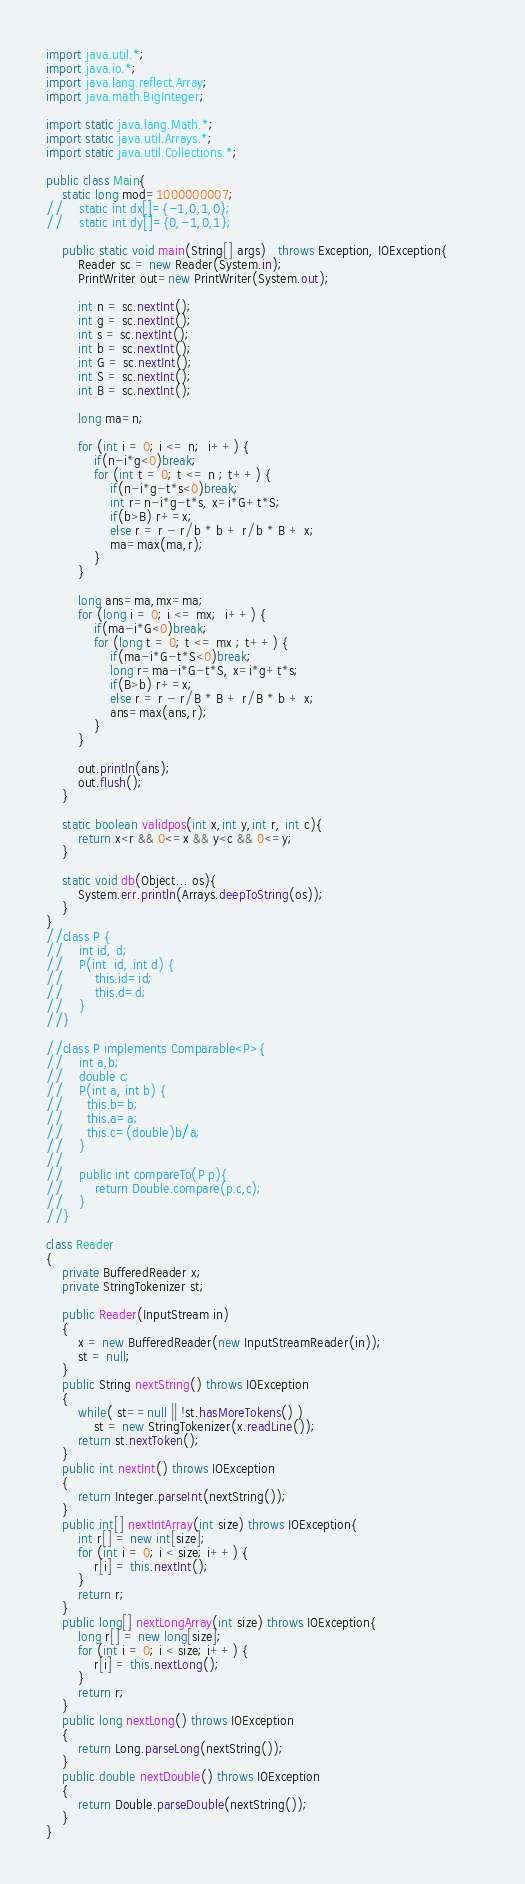Convert code to text. <code><loc_0><loc_0><loc_500><loc_500><_Java_>import java.util.*;
import java.io.*;
import java.lang.reflect.Array;
import java.math.BigInteger;

import static java.lang.Math.*;
import static java.util.Arrays.*;
import static java.util.Collections.*;
 
public class Main{
    static long mod=1000000007;
//    static int dx[]={-1,0,1,0};
//    static int dy[]={0,-1,0,1};

    public static void main(String[] args)   throws Exception, IOException{        
        Reader sc = new Reader(System.in);
        PrintWriter out=new PrintWriter(System.out);

        int n = sc.nextInt();
        int g = sc.nextInt();
        int s = sc.nextInt();
        int b = sc.nextInt();
        int G = sc.nextInt();
        int S = sc.nextInt();
        int B = sc.nextInt();

        long ma=n;
        
        for (int i = 0; i <= n;  i++) {
        	if(n-i*g<0)break;
			for (int t = 0; t <= n ; t++) {
	        	if(n-i*g-t*s<0)break;
				int r=n-i*g-t*s, x=i*G+t*S;
				if(b>B) r+=x;
				else r = r - r/b * b + r/b * B + x;
				ma=max(ma,r);
			}
		}
        
        long ans=ma,mx=ma;
        for (long i = 0; i <= mx;  i++) {
        	if(ma-i*G<0)break;
			for (long t = 0; t <= mx ; t++) {
	        	if(ma-i*G-t*S<0)break;
				long r=ma-i*G-t*S, x=i*g+t*s;
				if(B>b) r+=x;
				else r = r - r/B * B + r/B * b + x;
				ans=max(ans,r);
			}
		}

        out.println(ans);
        out.flush();
    }

    static boolean validpos(int x,int y,int r, int c){
        return x<r && 0<=x && y<c && 0<=y;
    }

    static void db(Object... os){
        System.err.println(Arrays.deepToString(os));
    }
}
//class P {
//    int id, d;
//    P(int  id, int d) {
//        this.id=id;
//        this.d=d;
//    }
//}

//class P implements Comparable<P>{
//    int a,b;
//    double c;
//    P(int a, int b) {
//    	this.b=b;
//    	this.a=a;
//    	this.c=(double)b/a;
//    }
//
//    public int compareTo(P p){
//        return Double.compare(p.c,c);
//    }
//}

class Reader
{ 
    private BufferedReader x;
    private StringTokenizer st;
    
    public Reader(InputStream in)
    {
        x = new BufferedReader(new InputStreamReader(in));
        st = null;
    }
    public String nextString() throws IOException
    {
        while( st==null || !st.hasMoreTokens() )
            st = new StringTokenizer(x.readLine());
        return st.nextToken();
    }
    public int nextInt() throws IOException
    {
        return Integer.parseInt(nextString());
    }
    public int[] nextIntArray(int size) throws IOException{
        int r[] = new int[size];
        for (int i = 0; i < size; i++) {
            r[i] = this.nextInt(); 
        }
        return r;
    }
    public long[] nextLongArray(int size) throws IOException{
        long r[] = new long[size];
        for (int i = 0; i < size; i++) {
            r[i] = this.nextLong(); 
        }
        return r;
    }
    public long nextLong() throws IOException
    {
        return Long.parseLong(nextString());
    }
    public double nextDouble() throws IOException
    {
        return Double.parseDouble(nextString());
    }
}
</code> 